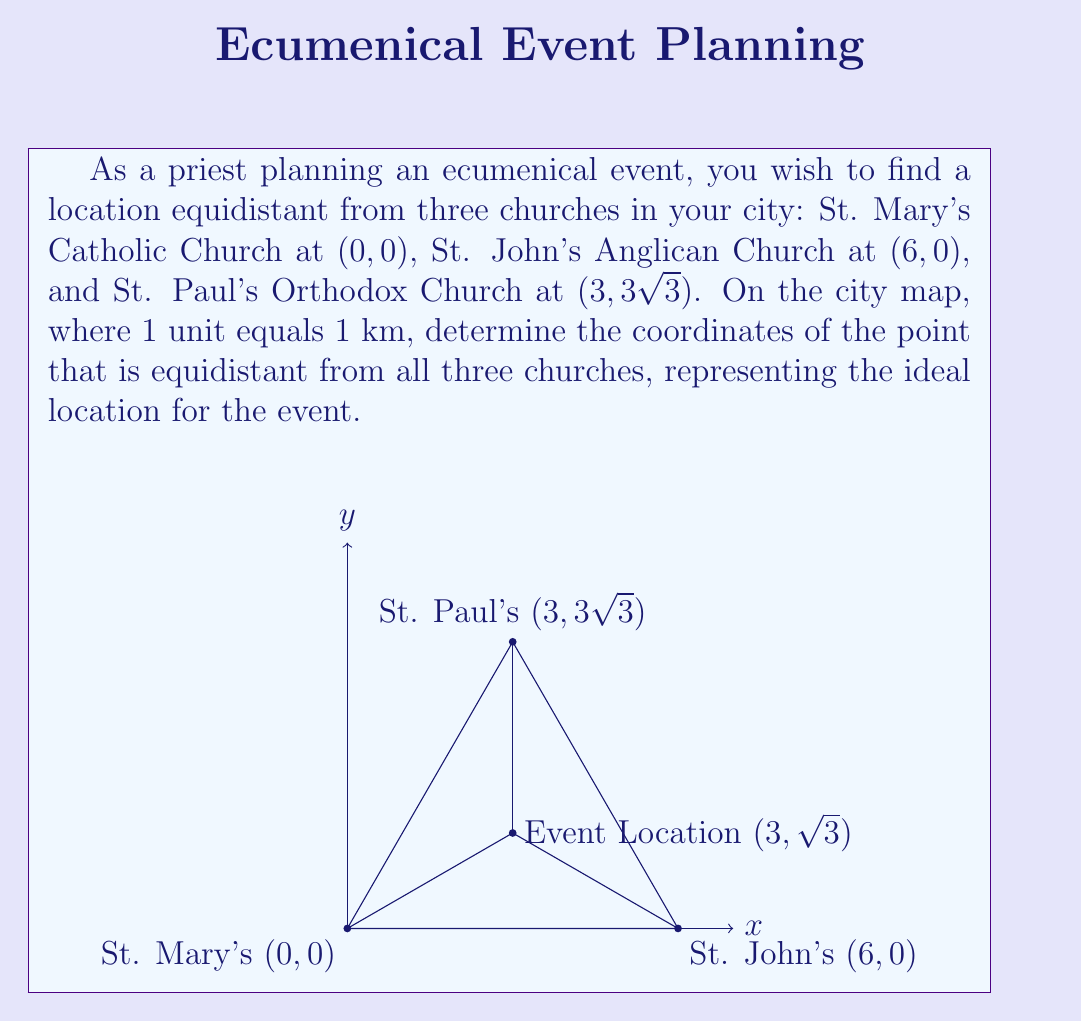Give your solution to this math problem. To solve this problem, we need to find the center of the circle that passes through all three points. This point will be equidistant from all three churches.

Step 1: Recognize that the three churches form an equilateral triangle.
- The distance between St. Mary's and St. John's is 6 units.
- The coordinates of St. Paul's (3, 3√3) form a 30-60-90 triangle with the other two churches.

Step 2: Identify that the center of the circle circumscribing an equilateral triangle is located at the intersection of its medians.

Step 3: Calculate the x-coordinate of the center point.
- The x-coordinate will be halfway between St. Mary's and St. John's:
$$ x = \frac{0 + 6}{2} = 3 $$

Step 4: Calculate the y-coordinate of the center point.
- The y-coordinate will be the height of the equilateral triangle multiplied by 1/3:
$$ y = \frac{1}{3} \cdot 3\sqrt{3} = \sqrt{3} $$

Step 5: Verify the result.
- The distance from the center point (3, √3) to each church should be equal.
- We can calculate this using the distance formula:
$$ d = \sqrt{(x_2-x_1)^2 + (y_2-y_1)^2} $$
- For each church, this distance equals 3 units, confirming our solution.

This location at (3, √3) km on the map represents the ideal spot for the ecumenical event, symbolizing unity and equal accessibility for all three congregations.
Answer: The coordinates of the point equidistant from all three churches are (3, √3). 